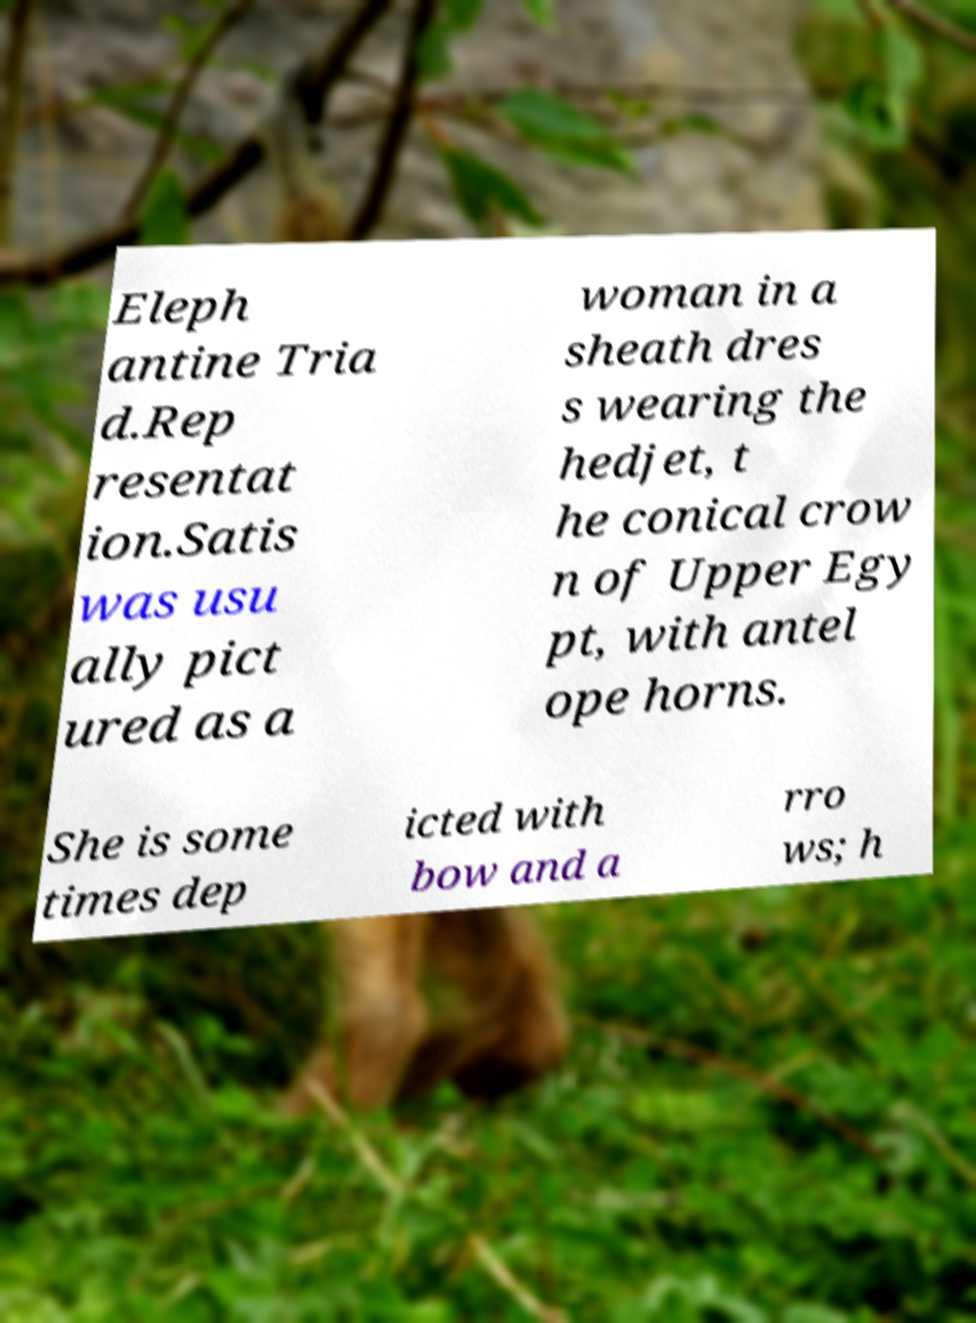Please read and relay the text visible in this image. What does it say? Eleph antine Tria d.Rep resentat ion.Satis was usu ally pict ured as a woman in a sheath dres s wearing the hedjet, t he conical crow n of Upper Egy pt, with antel ope horns. She is some times dep icted with bow and a rro ws; h 